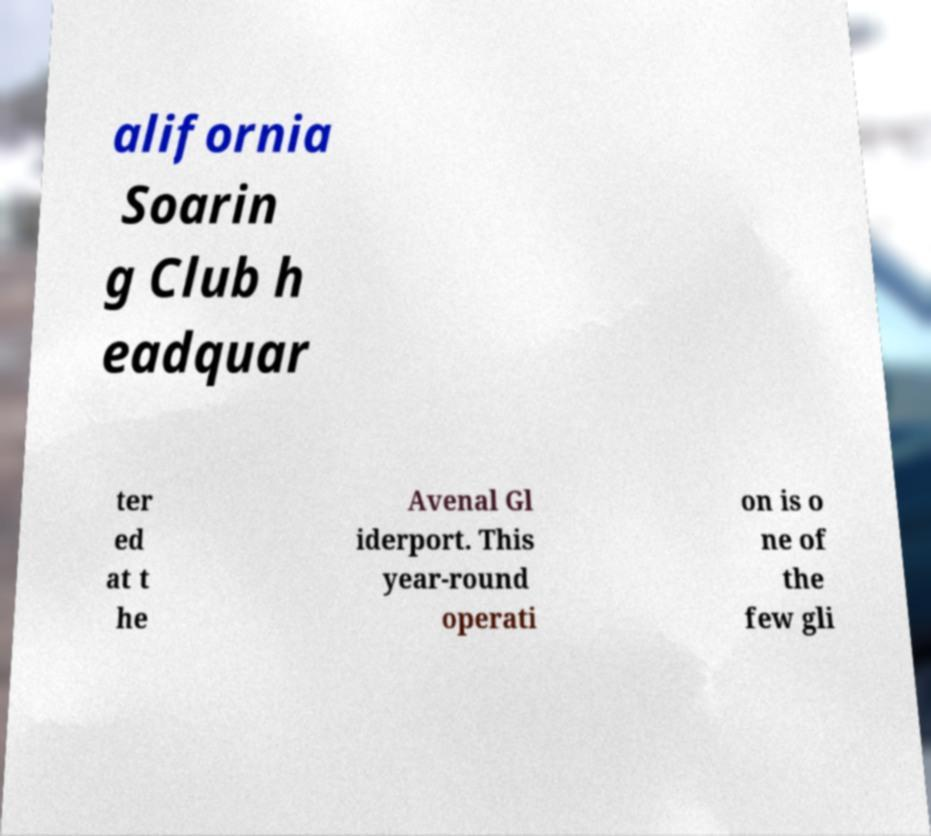Can you accurately transcribe the text from the provided image for me? alifornia Soarin g Club h eadquar ter ed at t he Avenal Gl iderport. This year-round operati on is o ne of the few gli 